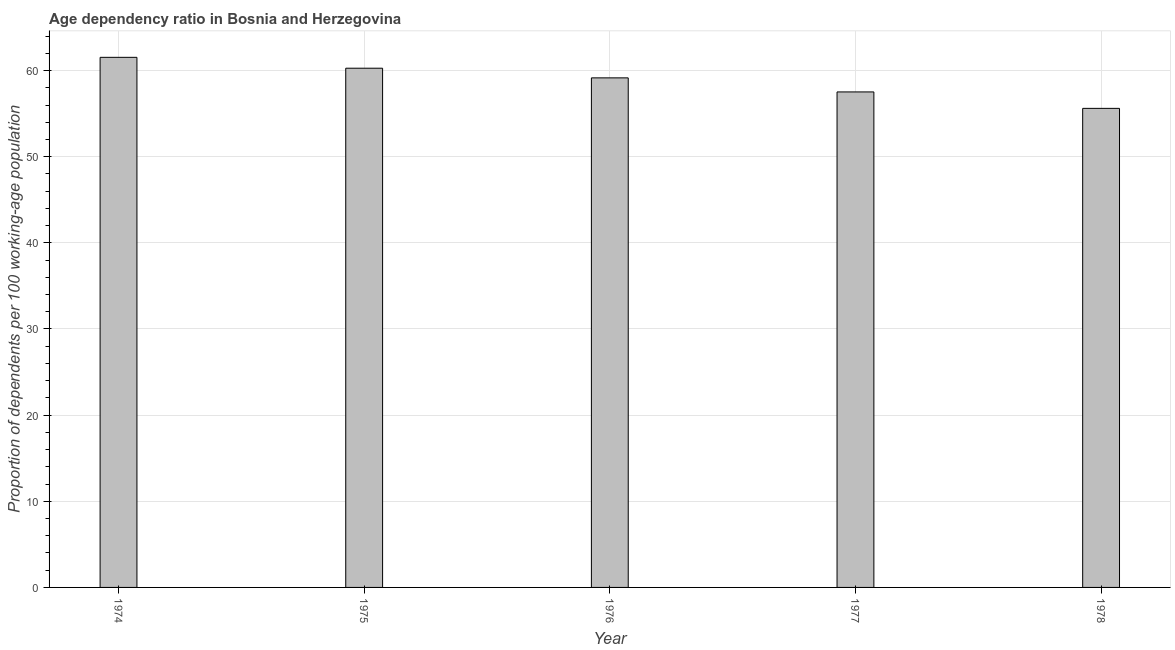Does the graph contain grids?
Offer a very short reply. Yes. What is the title of the graph?
Provide a succinct answer. Age dependency ratio in Bosnia and Herzegovina. What is the label or title of the Y-axis?
Ensure brevity in your answer.  Proportion of dependents per 100 working-age population. What is the age dependency ratio in 1977?
Your answer should be compact. 57.52. Across all years, what is the maximum age dependency ratio?
Provide a succinct answer. 61.53. Across all years, what is the minimum age dependency ratio?
Offer a terse response. 55.61. In which year was the age dependency ratio maximum?
Give a very brief answer. 1974. In which year was the age dependency ratio minimum?
Offer a terse response. 1978. What is the sum of the age dependency ratio?
Your answer should be compact. 294.08. What is the difference between the age dependency ratio in 1975 and 1977?
Your response must be concise. 2.75. What is the average age dependency ratio per year?
Provide a succinct answer. 58.82. What is the median age dependency ratio?
Your answer should be very brief. 59.15. In how many years, is the age dependency ratio greater than 40 ?
Your answer should be very brief. 5. Do a majority of the years between 1975 and 1974 (inclusive) have age dependency ratio greater than 26 ?
Give a very brief answer. No. What is the ratio of the age dependency ratio in 1975 to that in 1976?
Your response must be concise. 1.02. Is the difference between the age dependency ratio in 1974 and 1977 greater than the difference between any two years?
Give a very brief answer. No. What is the difference between the highest and the second highest age dependency ratio?
Provide a short and direct response. 1.26. Is the sum of the age dependency ratio in 1976 and 1978 greater than the maximum age dependency ratio across all years?
Make the answer very short. Yes. What is the difference between the highest and the lowest age dependency ratio?
Offer a very short reply. 5.92. In how many years, is the age dependency ratio greater than the average age dependency ratio taken over all years?
Provide a short and direct response. 3. How many bars are there?
Offer a very short reply. 5. Are all the bars in the graph horizontal?
Give a very brief answer. No. What is the Proportion of dependents per 100 working-age population of 1974?
Your answer should be compact. 61.53. What is the Proportion of dependents per 100 working-age population in 1975?
Your answer should be very brief. 60.27. What is the Proportion of dependents per 100 working-age population in 1976?
Ensure brevity in your answer.  59.15. What is the Proportion of dependents per 100 working-age population in 1977?
Give a very brief answer. 57.52. What is the Proportion of dependents per 100 working-age population in 1978?
Your answer should be compact. 55.61. What is the difference between the Proportion of dependents per 100 working-age population in 1974 and 1975?
Your response must be concise. 1.26. What is the difference between the Proportion of dependents per 100 working-age population in 1974 and 1976?
Your response must be concise. 2.38. What is the difference between the Proportion of dependents per 100 working-age population in 1974 and 1977?
Your answer should be compact. 4.02. What is the difference between the Proportion of dependents per 100 working-age population in 1974 and 1978?
Provide a short and direct response. 5.92. What is the difference between the Proportion of dependents per 100 working-age population in 1975 and 1976?
Offer a terse response. 1.12. What is the difference between the Proportion of dependents per 100 working-age population in 1975 and 1977?
Your answer should be compact. 2.75. What is the difference between the Proportion of dependents per 100 working-age population in 1975 and 1978?
Your answer should be compact. 4.66. What is the difference between the Proportion of dependents per 100 working-age population in 1976 and 1977?
Your answer should be compact. 1.63. What is the difference between the Proportion of dependents per 100 working-age population in 1976 and 1978?
Your answer should be compact. 3.54. What is the difference between the Proportion of dependents per 100 working-age population in 1977 and 1978?
Your answer should be very brief. 1.91. What is the ratio of the Proportion of dependents per 100 working-age population in 1974 to that in 1976?
Ensure brevity in your answer.  1.04. What is the ratio of the Proportion of dependents per 100 working-age population in 1974 to that in 1977?
Ensure brevity in your answer.  1.07. What is the ratio of the Proportion of dependents per 100 working-age population in 1974 to that in 1978?
Provide a short and direct response. 1.11. What is the ratio of the Proportion of dependents per 100 working-age population in 1975 to that in 1976?
Provide a succinct answer. 1.02. What is the ratio of the Proportion of dependents per 100 working-age population in 1975 to that in 1977?
Provide a succinct answer. 1.05. What is the ratio of the Proportion of dependents per 100 working-age population in 1975 to that in 1978?
Offer a very short reply. 1.08. What is the ratio of the Proportion of dependents per 100 working-age population in 1976 to that in 1977?
Provide a succinct answer. 1.03. What is the ratio of the Proportion of dependents per 100 working-age population in 1976 to that in 1978?
Your response must be concise. 1.06. What is the ratio of the Proportion of dependents per 100 working-age population in 1977 to that in 1978?
Your response must be concise. 1.03. 